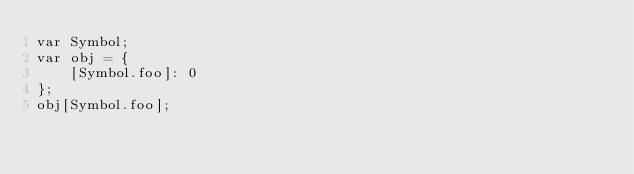Convert code to text. <code><loc_0><loc_0><loc_500><loc_500><_JavaScript_>var Symbol;
var obj = {
    [Symbol.foo]: 0
};
obj[Symbol.foo];
</code> 